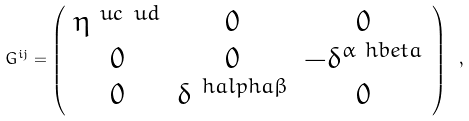Convert formula to latex. <formula><loc_0><loc_0><loc_500><loc_500>G ^ { i j } = \left ( \begin{array} { c c c } \eta ^ { \ u c \ u d } & 0 & 0 \\ 0 & 0 & - \delta ^ { \alpha \ h b e t a } \\ 0 & \delta ^ { \ h a l p h a \beta } & 0 \\ \end{array} \right ) \ ,</formula> 